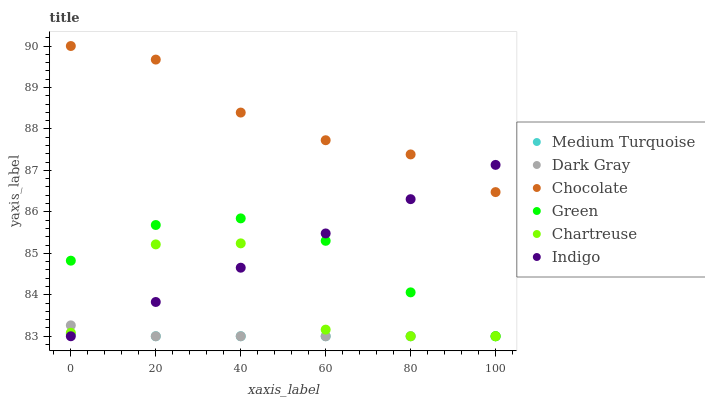Does Medium Turquoise have the minimum area under the curve?
Answer yes or no. Yes. Does Chocolate have the maximum area under the curve?
Answer yes or no. Yes. Does Dark Gray have the minimum area under the curve?
Answer yes or no. No. Does Dark Gray have the maximum area under the curve?
Answer yes or no. No. Is Indigo the smoothest?
Answer yes or no. Yes. Is Chartreuse the roughest?
Answer yes or no. Yes. Is Chocolate the smoothest?
Answer yes or no. No. Is Chocolate the roughest?
Answer yes or no. No. Does Indigo have the lowest value?
Answer yes or no. Yes. Does Chocolate have the lowest value?
Answer yes or no. No. Does Chocolate have the highest value?
Answer yes or no. Yes. Does Dark Gray have the highest value?
Answer yes or no. No. Is Chartreuse less than Chocolate?
Answer yes or no. Yes. Is Chocolate greater than Green?
Answer yes or no. Yes. Does Indigo intersect Dark Gray?
Answer yes or no. Yes. Is Indigo less than Dark Gray?
Answer yes or no. No. Is Indigo greater than Dark Gray?
Answer yes or no. No. Does Chartreuse intersect Chocolate?
Answer yes or no. No. 